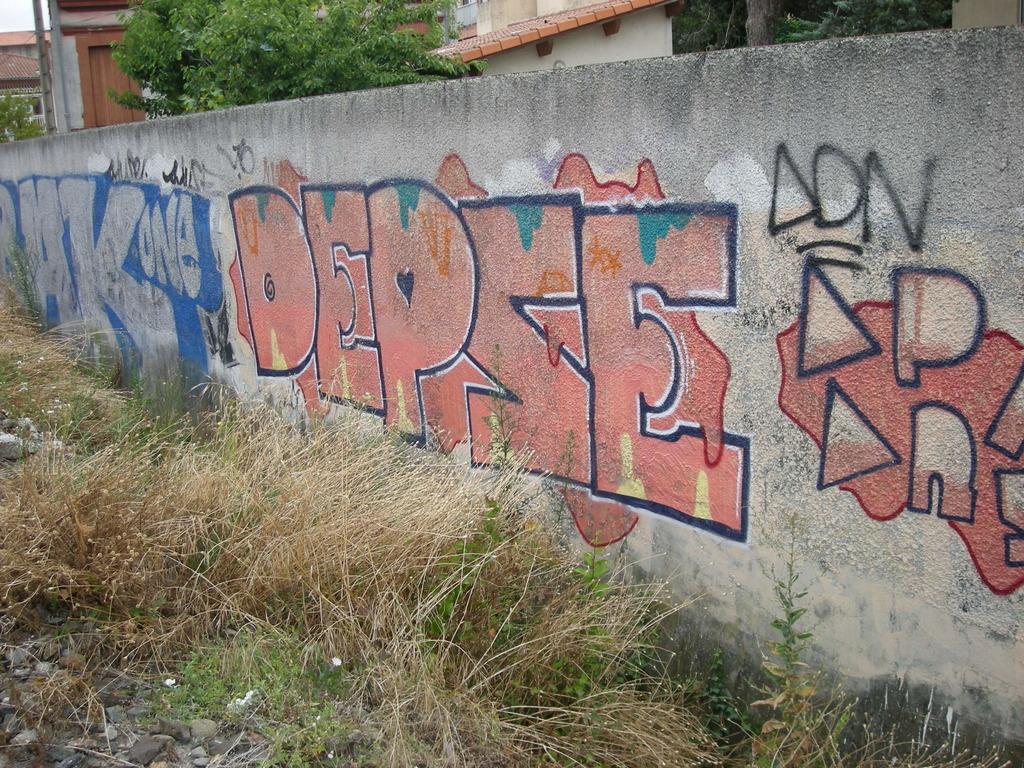How would you summarize this image in a sentence or two? In this image we can see a wall with paintings. At the bottom of the image there is the grass, stones and other objects. In the background of the image there are trees, houses, sky and other objects. 